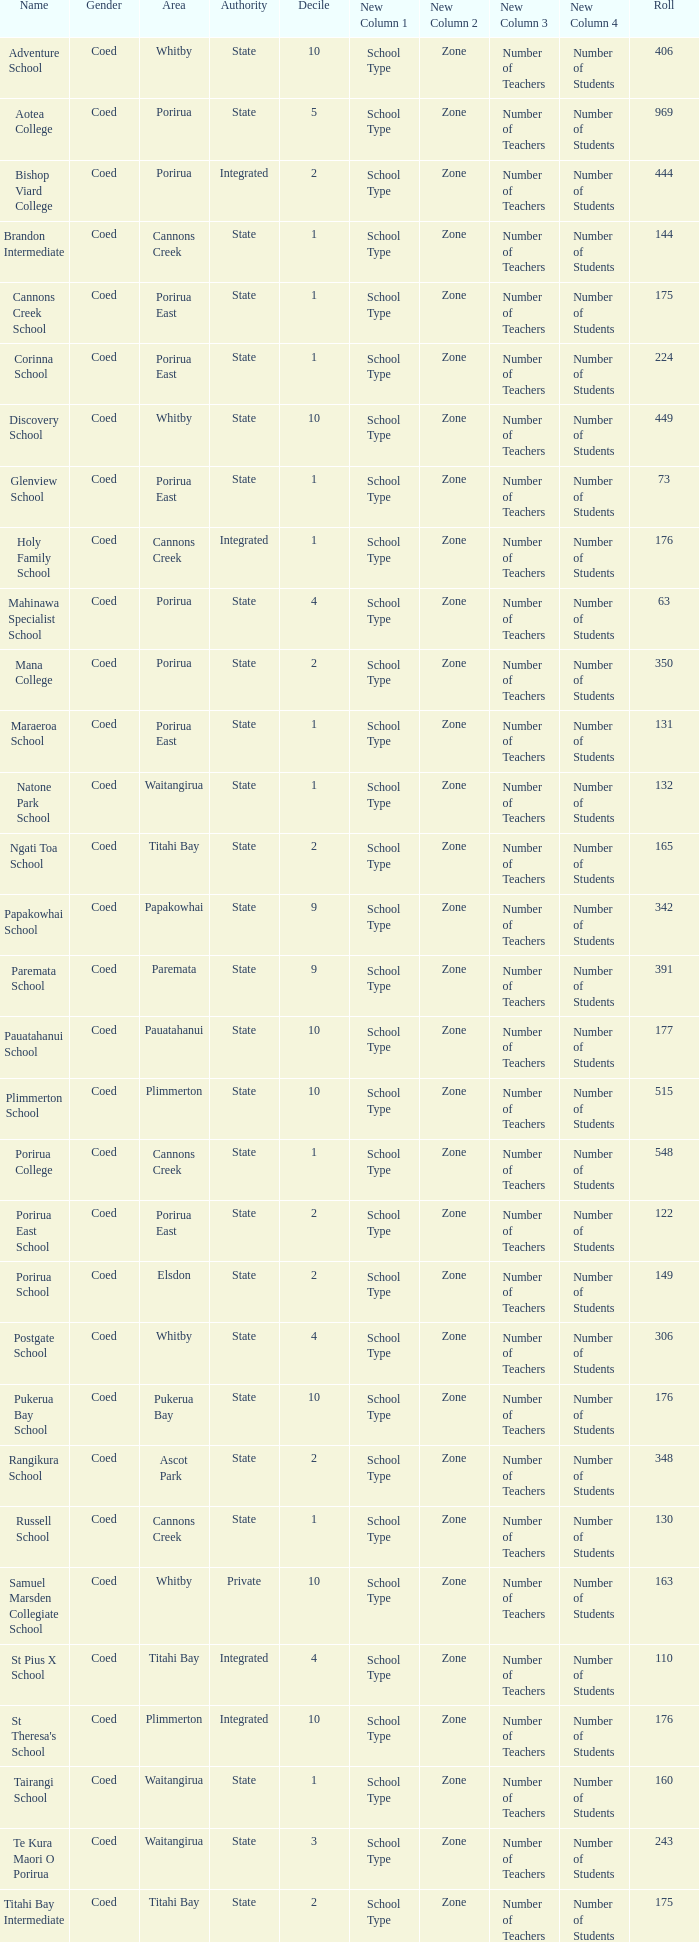What is the student population at bishop viard college (an integrated college) that has a decile greater than 1? 1.0. 